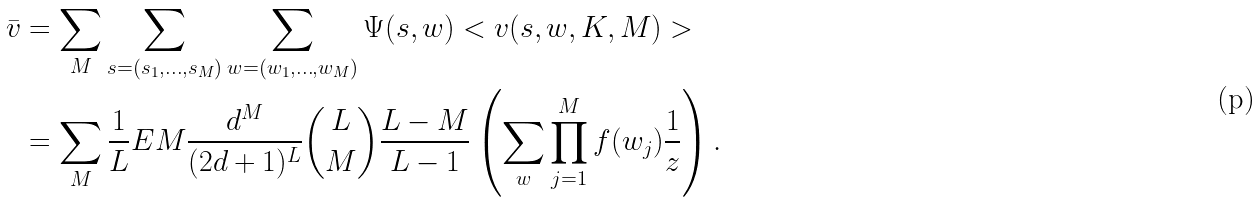<formula> <loc_0><loc_0><loc_500><loc_500>\bar { v } & = \sum _ { M } \sum _ { s = ( s _ { 1 } , \dots , s _ { M } ) } \sum _ { w = ( w _ { 1 } , \dots , w _ { M } ) } \Psi ( s , w ) < v ( s , w , K , M ) > \\ & = \sum _ { M } \frac { 1 } { L } E M \frac { d ^ { M } } { ( 2 d + 1 ) ^ { L } } { L \choose M } \frac { L - M } { L - 1 } \left ( \sum _ { w } \prod _ { j = 1 } ^ { M } f ( w _ { j } ) \frac { 1 } { z } \right ) .</formula> 